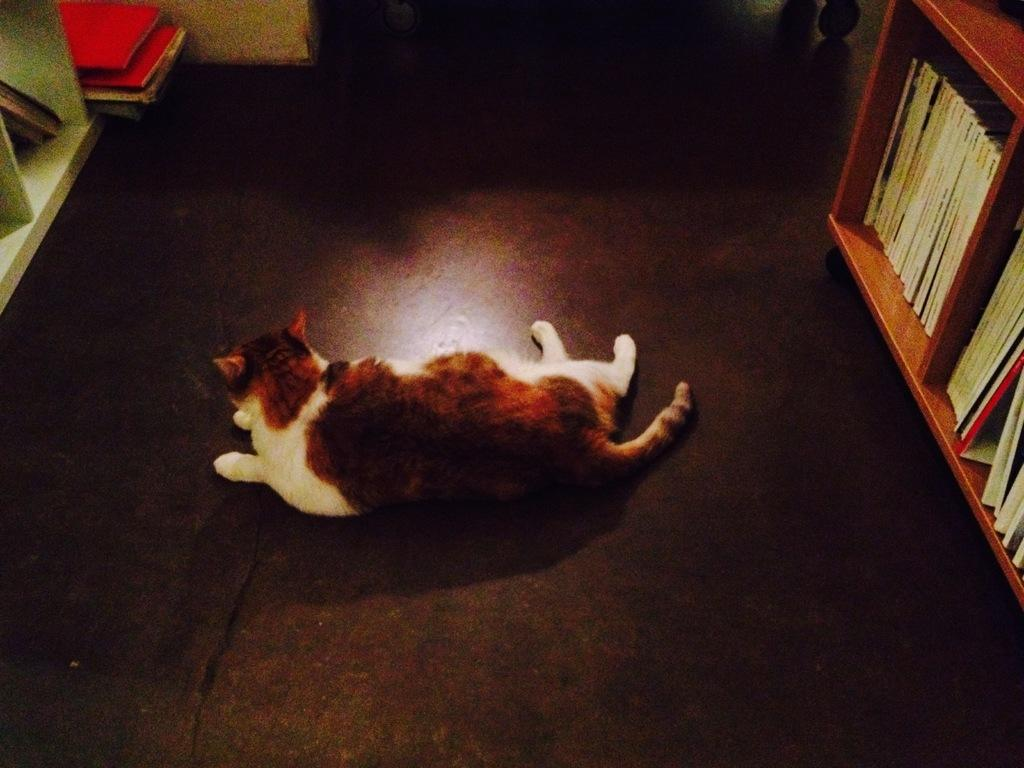What animal can be seen laying on the floor in the image? There is a cat laying on the floor in the image. Where are the books located in the image? The books are placed on racks on both the right and left sides of the image. Can you see a deer performing an operation on the cat in the image? No, there is no deer or operation present in the image. The image only shows a cat laying on the floor and books placed on racks. 